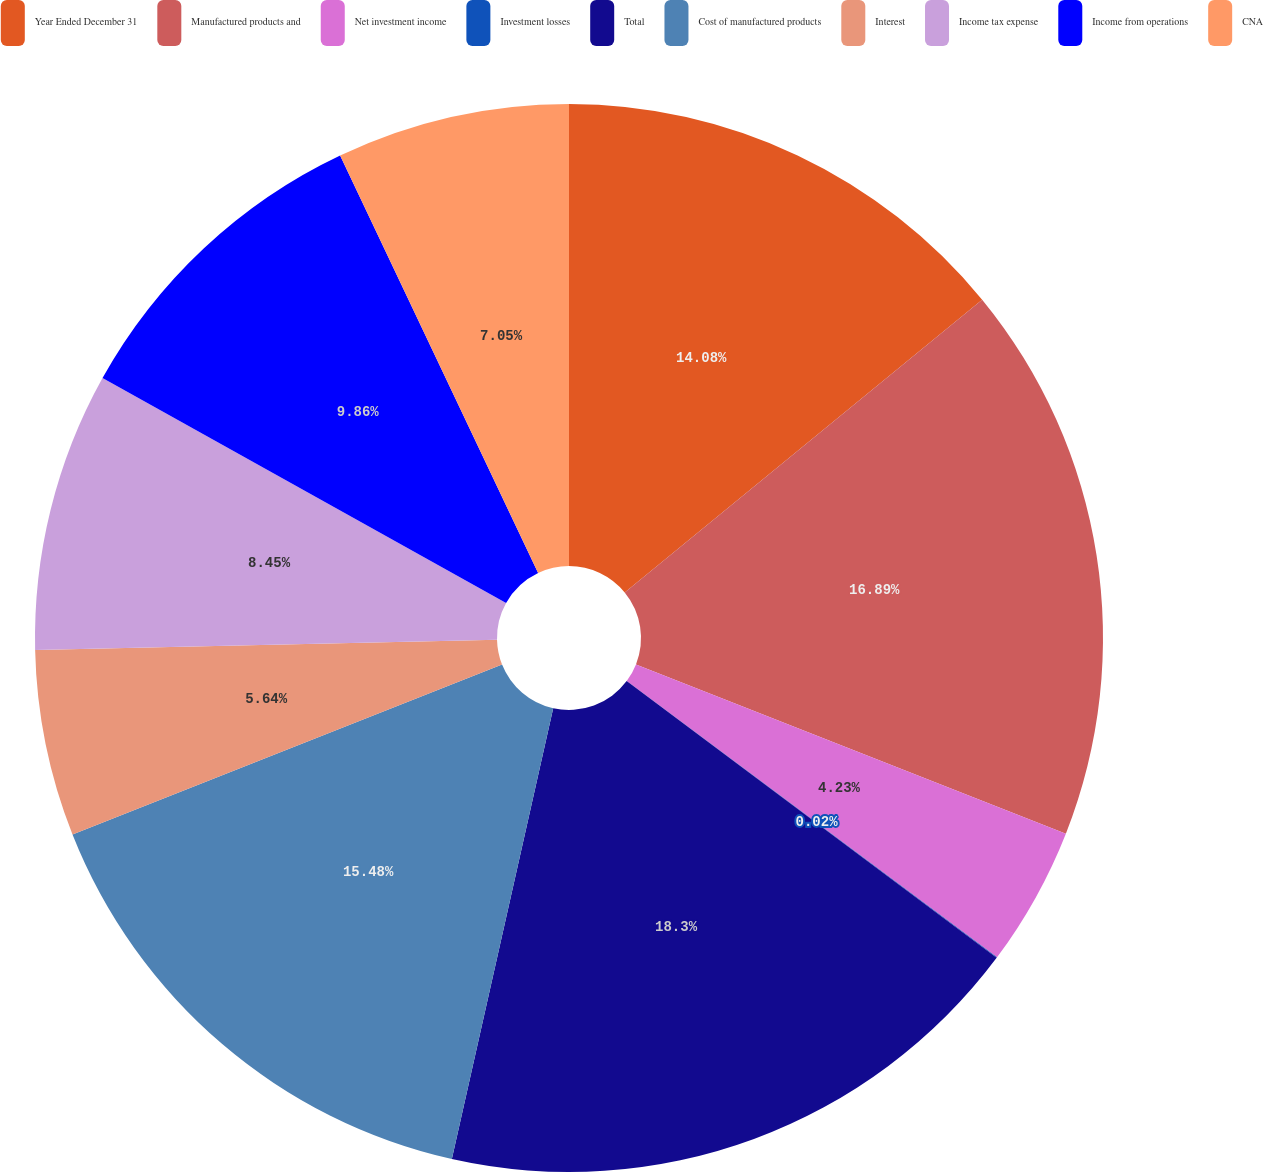Convert chart to OTSL. <chart><loc_0><loc_0><loc_500><loc_500><pie_chart><fcel>Year Ended December 31<fcel>Manufactured products and<fcel>Net investment income<fcel>Investment losses<fcel>Total<fcel>Cost of manufactured products<fcel>Interest<fcel>Income tax expense<fcel>Income from operations<fcel>CNA<nl><fcel>14.08%<fcel>16.89%<fcel>4.23%<fcel>0.02%<fcel>18.3%<fcel>15.48%<fcel>5.64%<fcel>8.45%<fcel>9.86%<fcel>7.05%<nl></chart> 